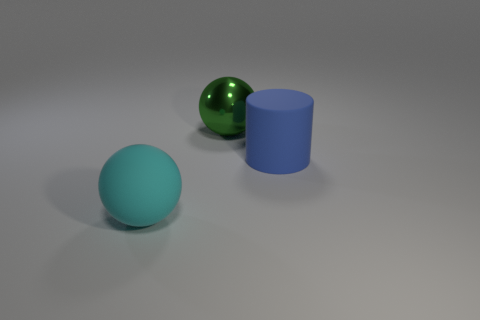What material is the big blue cylinder that is behind the cyan rubber ball that is on the left side of the green object made of?
Make the answer very short. Rubber. Are the large green sphere and the large object that is in front of the big blue object made of the same material?
Offer a terse response. No. What is the thing that is both behind the cyan rubber ball and in front of the metallic thing made of?
Your answer should be very brief. Rubber. What color is the big thing to the left of the ball right of the large cyan matte ball?
Provide a succinct answer. Cyan. What is the material of the object that is to the right of the large metal ball?
Offer a terse response. Rubber. Is the number of red matte blocks less than the number of blue rubber cylinders?
Provide a succinct answer. Yes. There is a green metallic object; is its shape the same as the large object that is in front of the big blue cylinder?
Your response must be concise. Yes. What is the shape of the object that is in front of the green metal ball and to the left of the large blue rubber object?
Provide a short and direct response. Sphere. Are there the same number of blue objects that are behind the rubber cylinder and big spheres that are on the left side of the green thing?
Offer a very short reply. No. Do the rubber thing that is in front of the large cylinder and the large green shiny object have the same shape?
Offer a very short reply. Yes. 